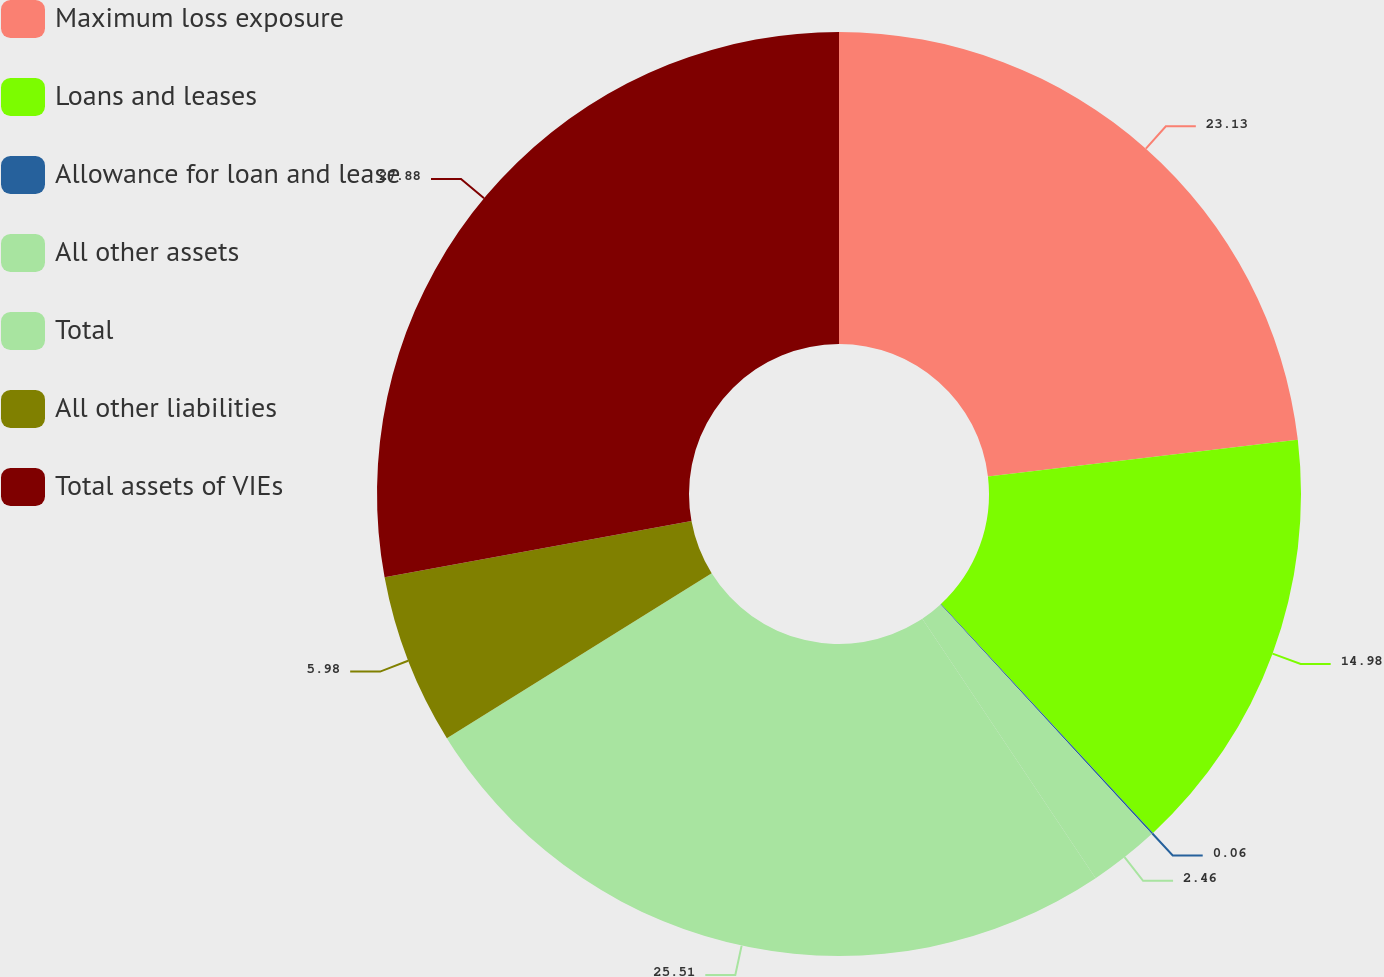Convert chart. <chart><loc_0><loc_0><loc_500><loc_500><pie_chart><fcel>Maximum loss exposure<fcel>Loans and leases<fcel>Allowance for loan and lease<fcel>All other assets<fcel>Total<fcel>All other liabilities<fcel>Total assets of VIEs<nl><fcel>23.13%<fcel>14.98%<fcel>0.06%<fcel>2.46%<fcel>25.51%<fcel>5.98%<fcel>27.89%<nl></chart> 